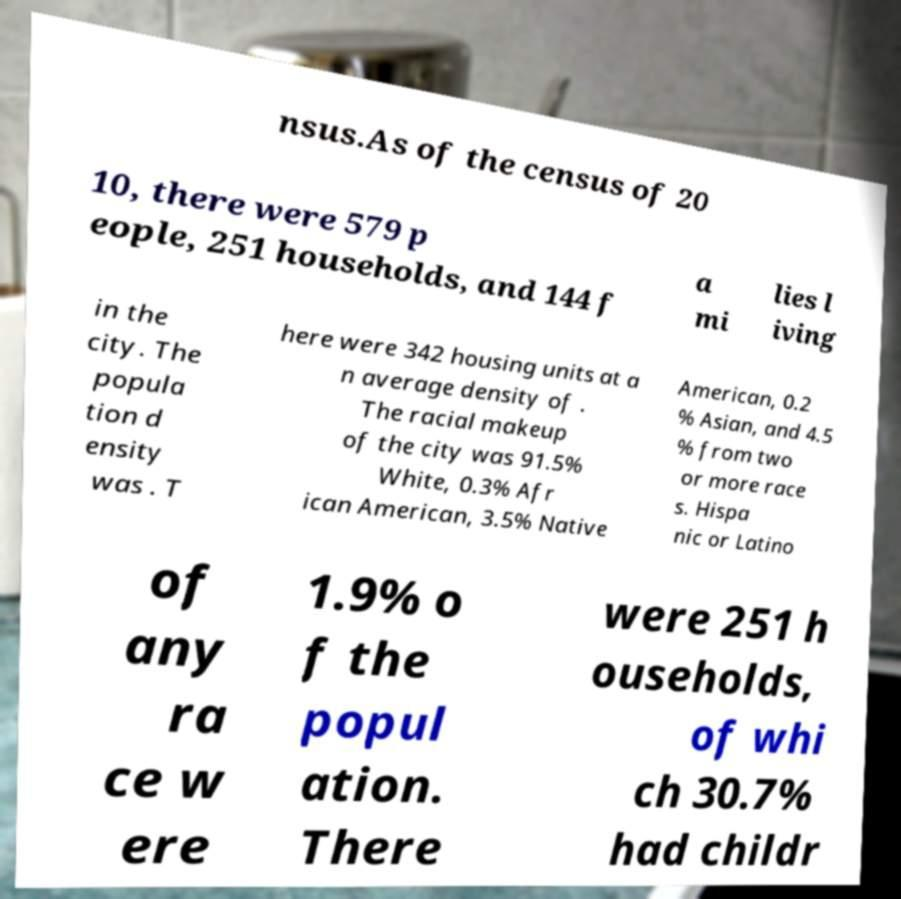Please identify and transcribe the text found in this image. nsus.As of the census of 20 10, there were 579 p eople, 251 households, and 144 f a mi lies l iving in the city. The popula tion d ensity was . T here were 342 housing units at a n average density of . The racial makeup of the city was 91.5% White, 0.3% Afr ican American, 3.5% Native American, 0.2 % Asian, and 4.5 % from two or more race s. Hispa nic or Latino of any ra ce w ere 1.9% o f the popul ation. There were 251 h ouseholds, of whi ch 30.7% had childr 